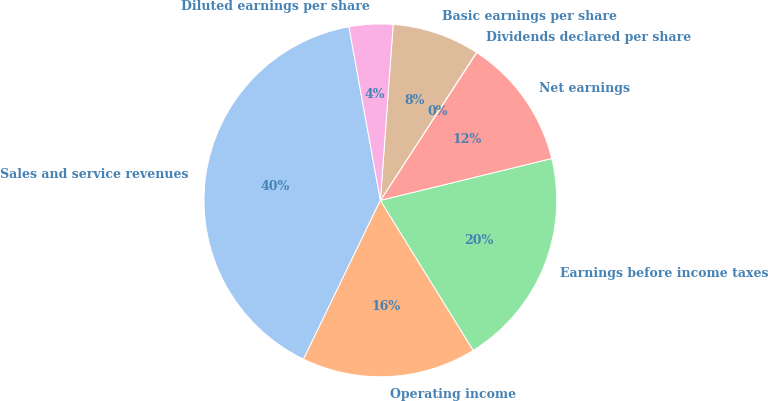Convert chart to OTSL. <chart><loc_0><loc_0><loc_500><loc_500><pie_chart><fcel>Sales and service revenues<fcel>Operating income<fcel>Earnings before income taxes<fcel>Net earnings<fcel>Dividends declared per share<fcel>Basic earnings per share<fcel>Diluted earnings per share<nl><fcel>39.97%<fcel>16.0%<fcel>19.99%<fcel>12.0%<fcel>0.02%<fcel>8.01%<fcel>4.01%<nl></chart> 